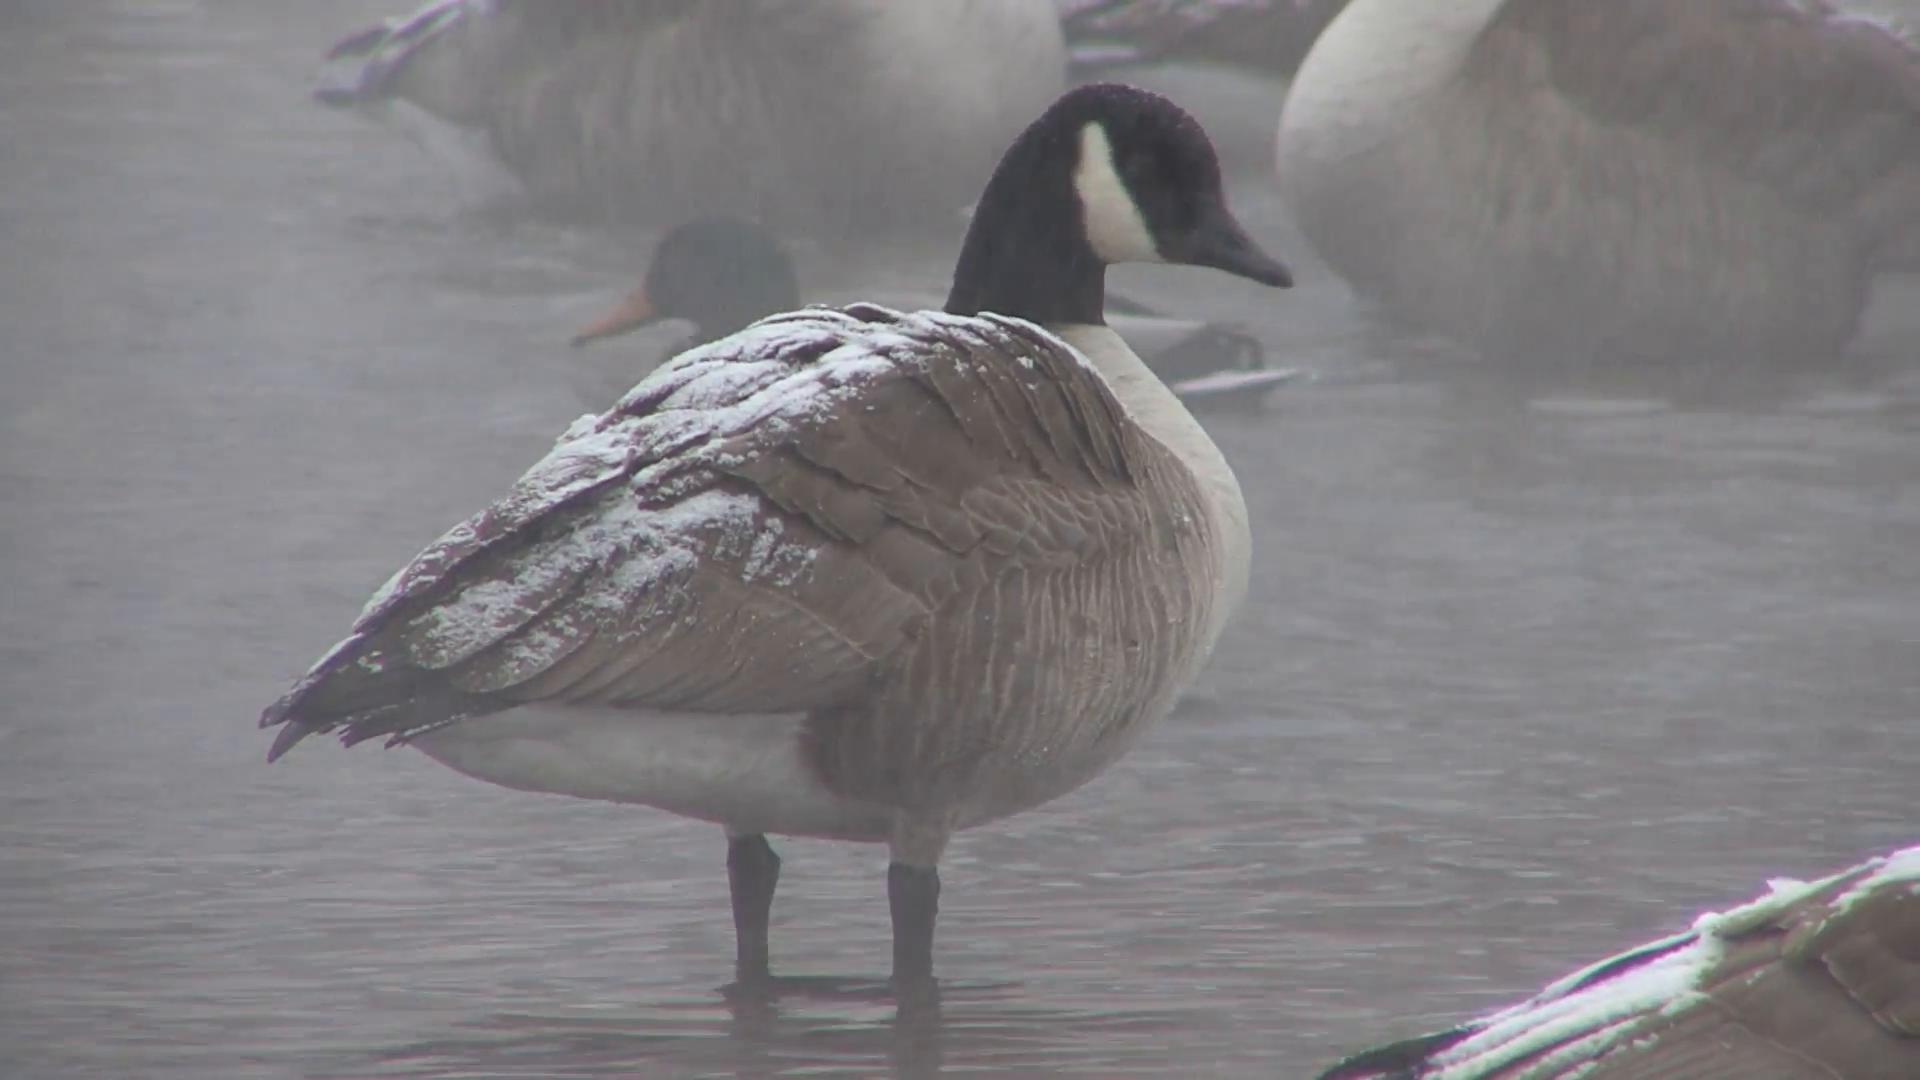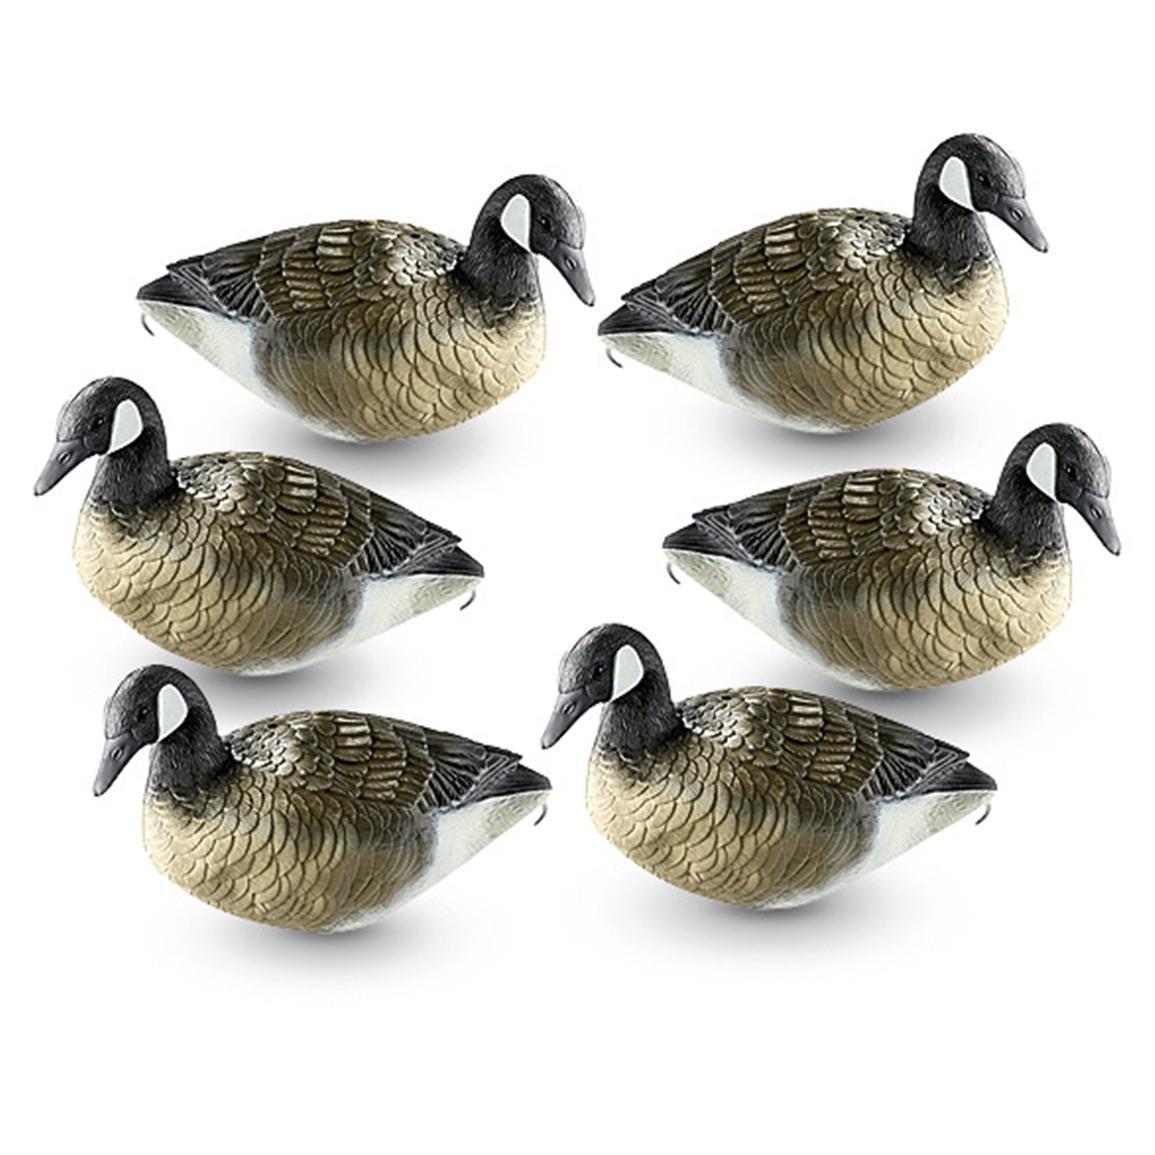The first image is the image on the left, the second image is the image on the right. Examine the images to the left and right. Is the description "Each image shows one goose, and in one image the goose is on water and posed with its neck curved back." accurate? Answer yes or no. No. 